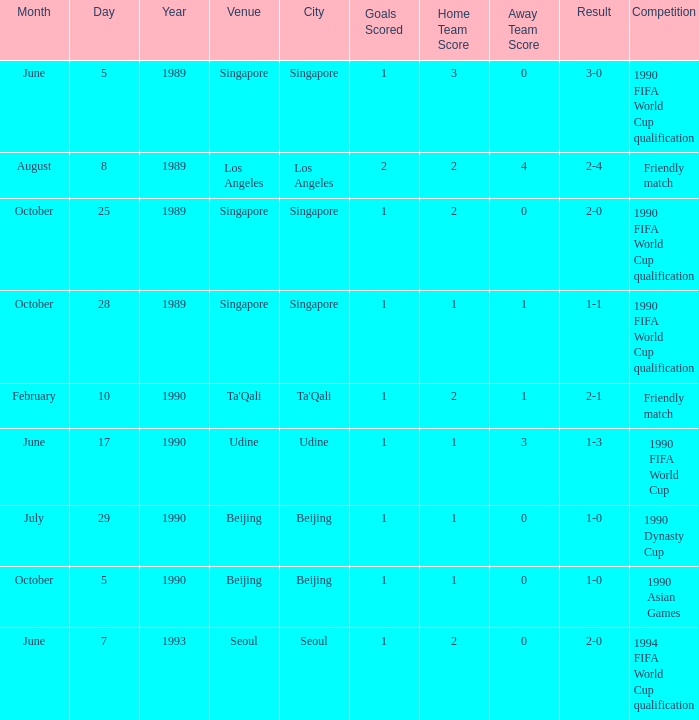On october 5, 1990, what was the result of the game? 1 goal. 